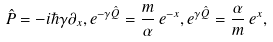Convert formula to latex. <formula><loc_0><loc_0><loc_500><loc_500>\hat { P } = - i \hbar { \gamma } \partial _ { x } , e ^ { - \gamma \hat { Q } } = \frac { m } { \alpha } \, e ^ { - x } , e ^ { \gamma \hat { Q } } = \frac { \alpha } { m } \, e ^ { x } ,</formula> 